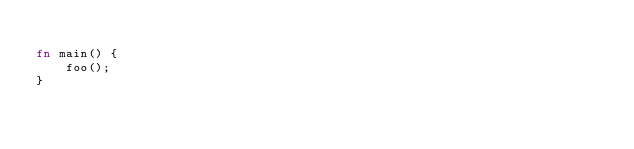Convert code to text. <code><loc_0><loc_0><loc_500><loc_500><_Rust_>
fn main() {
    foo();
}
</code> 